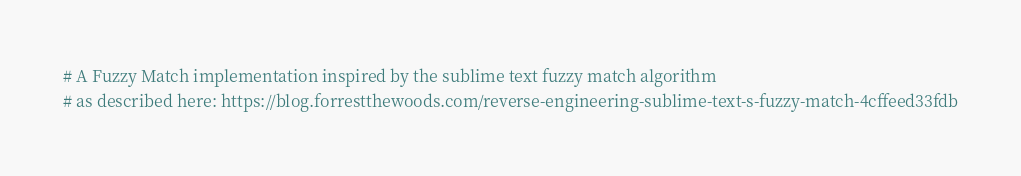Convert code to text. <code><loc_0><loc_0><loc_500><loc_500><_Nim_># A Fuzzy Match implementation inspired by the sublime text fuzzy match algorithm
# as described here: https://blog.forrestthewoods.com/reverse-engineering-sublime-text-s-fuzzy-match-4cffeed33fdb</code> 